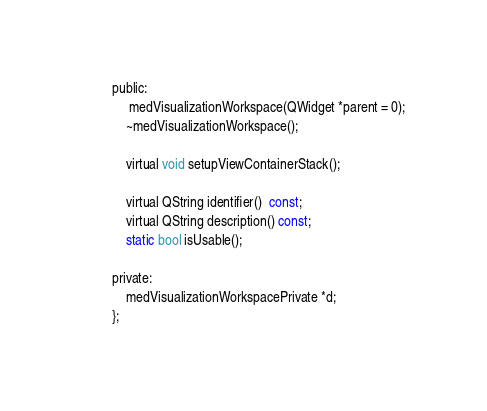Convert code to text. <code><loc_0><loc_0><loc_500><loc_500><_C_>public:
     medVisualizationWorkspace(QWidget *parent = 0);
    ~medVisualizationWorkspace();

    virtual void setupViewContainerStack();

    virtual QString identifier()  const;
    virtual QString description() const;
    static bool isUsable();

private:
    medVisualizationWorkspacePrivate *d;
};


</code> 